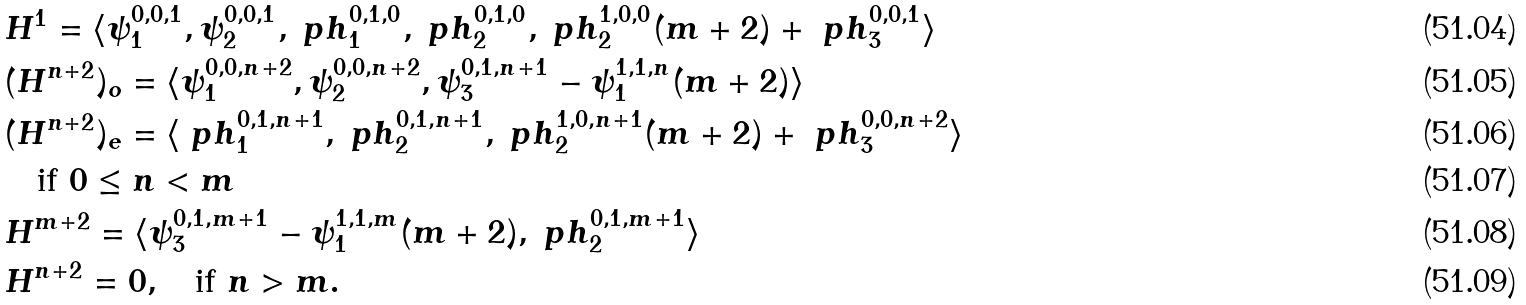<formula> <loc_0><loc_0><loc_500><loc_500>& H ^ { 1 } = \langle \psi ^ { 0 , 0 , 1 } _ { 1 } , \psi ^ { 0 , 0 , 1 } _ { 2 } , \ p h ^ { 0 , 1 , 0 } _ { 1 } , \ p h ^ { 0 , 1 , 0 } _ { 2 } , \ p h ^ { 1 , 0 , 0 } _ { 2 } ( m + 2 ) + \ p h ^ { 0 , 0 , 1 } _ { 3 } \rangle \\ & ( H ^ { n + 2 } ) _ { o } = \langle \psi ^ { 0 , 0 , n + 2 } _ { 1 } , \psi ^ { 0 , 0 , n + 2 } _ { 2 } , \psi ^ { 0 , 1 , n + 1 } _ { 3 } - \psi ^ { 1 , 1 , n } _ { 1 } ( m + 2 ) \rangle \\ & ( H ^ { n + 2 } ) _ { e } = \langle \ p h ^ { 0 , 1 , n + 1 } _ { 1 } , \ p h ^ { 0 , 1 , n + 1 } _ { 2 } , \ p h ^ { 1 , 0 , n + 1 } _ { 2 } ( m + 2 ) + \ p h ^ { 0 , 0 , n + 2 } _ { 3 } \rangle \\ & \quad \text {if $0\leq n<m$} \\ & H ^ { m + 2 } = \langle \psi ^ { 0 , 1 , m + 1 } _ { 3 } - \psi ^ { 1 , 1 , m } _ { 1 } ( m + 2 ) , \ p h ^ { 0 , 1 , m + 1 } _ { 2 } \rangle \\ & H ^ { n + 2 } = 0 , \quad \text {if $n>m$} .</formula> 